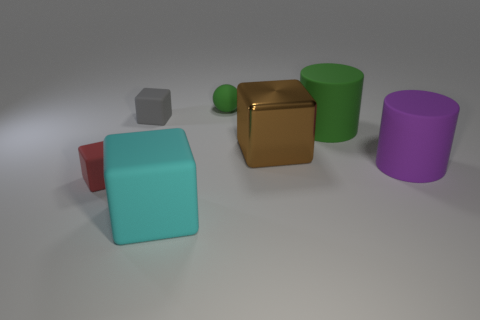Subtract all gray matte cubes. How many cubes are left? 3 Subtract all gray blocks. How many blocks are left? 3 Add 3 matte blocks. How many objects exist? 10 Subtract all balls. How many objects are left? 6 Subtract all cyan cubes. Subtract all yellow balls. How many cubes are left? 3 Subtract all cyan balls. How many yellow blocks are left? 0 Subtract all tiny red rubber objects. Subtract all large cubes. How many objects are left? 4 Add 6 tiny matte blocks. How many tiny matte blocks are left? 8 Add 5 cyan matte cubes. How many cyan matte cubes exist? 6 Subtract 0 gray balls. How many objects are left? 7 